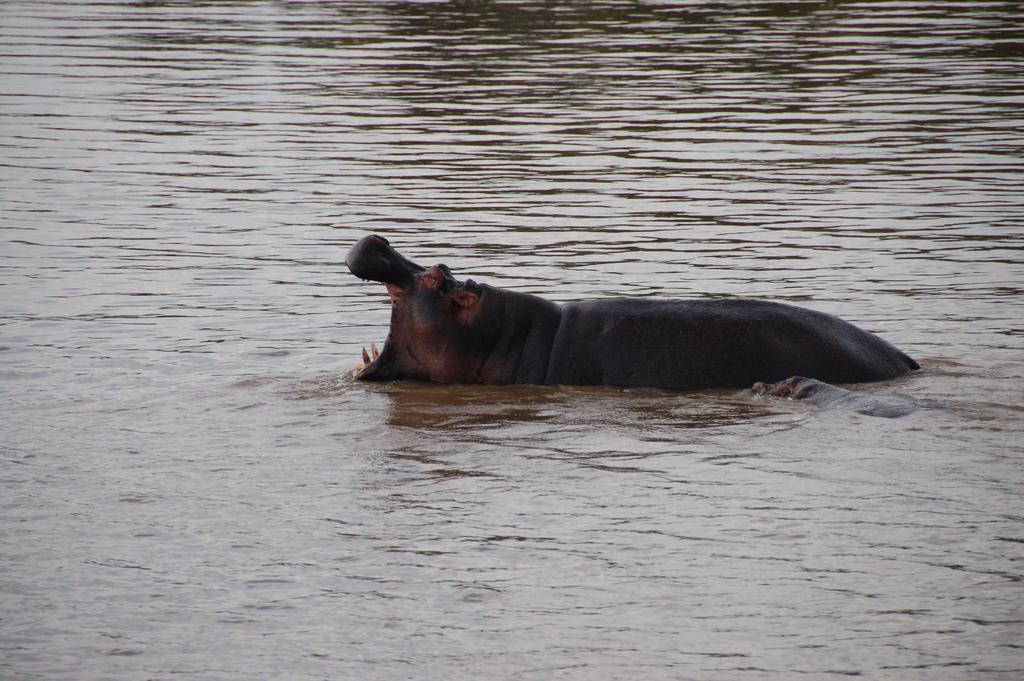How would you summarize this image in a sentence or two? In this image there is a hippopotamus in the water. Its mouth is wide opened. Around it there is the water. 